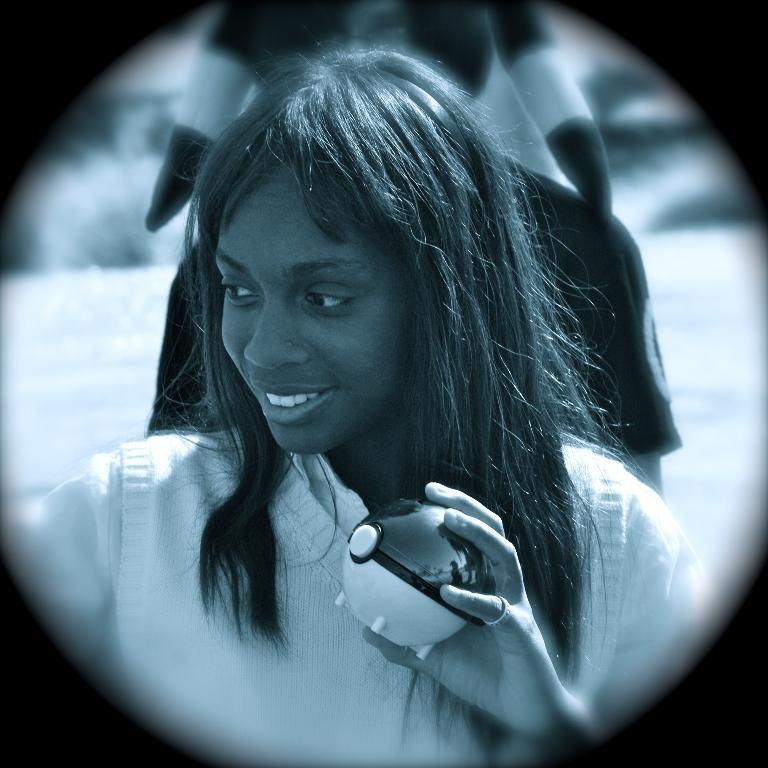Who is the main subject in the image? There is a lady in the image. Where is the lady positioned in the image? The lady is standing in the center of the image. What is the lady holding in her hand? The lady is holding a pokeball in her hand. What type of agreement is being discussed by the geese in the image? There are no geese present in the image, and therefore no discussion of agreements can be observed. 